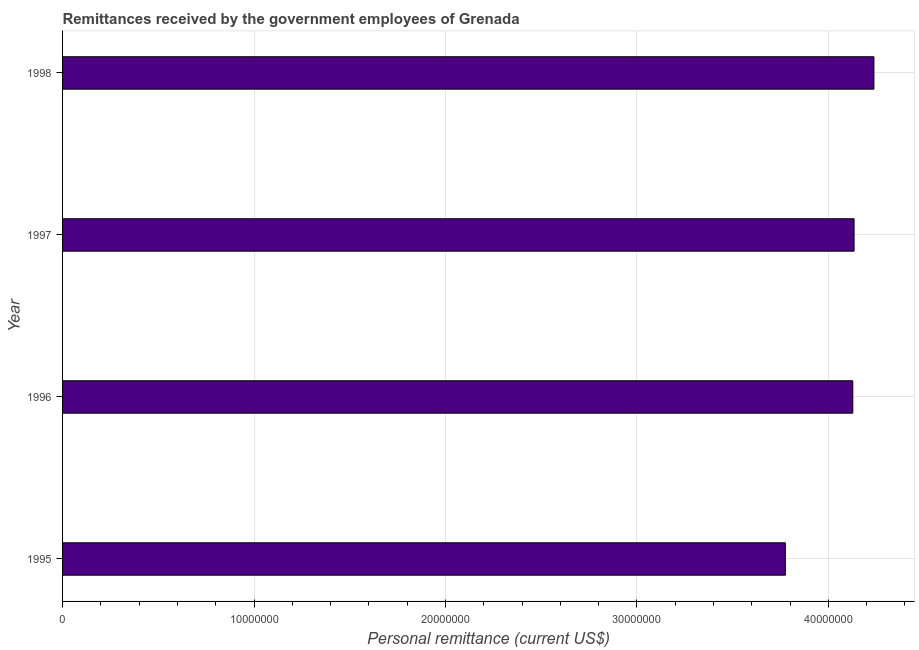What is the title of the graph?
Provide a short and direct response. Remittances received by the government employees of Grenada. What is the label or title of the X-axis?
Offer a very short reply. Personal remittance (current US$). What is the label or title of the Y-axis?
Your answer should be compact. Year. What is the personal remittances in 1998?
Make the answer very short. 4.24e+07. Across all years, what is the maximum personal remittances?
Give a very brief answer. 4.24e+07. Across all years, what is the minimum personal remittances?
Offer a very short reply. 3.78e+07. In which year was the personal remittances minimum?
Offer a very short reply. 1995. What is the sum of the personal remittances?
Your answer should be very brief. 1.63e+08. What is the difference between the personal remittances in 1995 and 1996?
Your answer should be compact. -3.52e+06. What is the average personal remittances per year?
Provide a short and direct response. 4.07e+07. What is the median personal remittances?
Ensure brevity in your answer.  4.13e+07. What is the ratio of the personal remittances in 1997 to that in 1998?
Your answer should be very brief. 0.98. Is the difference between the personal remittances in 1996 and 1997 greater than the difference between any two years?
Offer a terse response. No. What is the difference between the highest and the second highest personal remittances?
Your answer should be very brief. 1.04e+06. Is the sum of the personal remittances in 1997 and 1998 greater than the maximum personal remittances across all years?
Your answer should be very brief. Yes. What is the difference between the highest and the lowest personal remittances?
Offer a terse response. 4.63e+06. In how many years, is the personal remittances greater than the average personal remittances taken over all years?
Your response must be concise. 3. Are all the bars in the graph horizontal?
Your response must be concise. Yes. How many years are there in the graph?
Your answer should be compact. 4. Are the values on the major ticks of X-axis written in scientific E-notation?
Your answer should be compact. No. What is the Personal remittance (current US$) in 1995?
Provide a succinct answer. 3.78e+07. What is the Personal remittance (current US$) in 1996?
Your response must be concise. 4.13e+07. What is the Personal remittance (current US$) in 1997?
Provide a short and direct response. 4.13e+07. What is the Personal remittance (current US$) of 1998?
Offer a very short reply. 4.24e+07. What is the difference between the Personal remittance (current US$) in 1995 and 1996?
Make the answer very short. -3.52e+06. What is the difference between the Personal remittance (current US$) in 1995 and 1997?
Ensure brevity in your answer.  -3.59e+06. What is the difference between the Personal remittance (current US$) in 1995 and 1998?
Give a very brief answer. -4.63e+06. What is the difference between the Personal remittance (current US$) in 1996 and 1997?
Provide a succinct answer. -6.67e+04. What is the difference between the Personal remittance (current US$) in 1996 and 1998?
Offer a terse response. -1.10e+06. What is the difference between the Personal remittance (current US$) in 1997 and 1998?
Ensure brevity in your answer.  -1.04e+06. What is the ratio of the Personal remittance (current US$) in 1995 to that in 1996?
Provide a short and direct response. 0.92. What is the ratio of the Personal remittance (current US$) in 1995 to that in 1997?
Your answer should be compact. 0.91. What is the ratio of the Personal remittance (current US$) in 1995 to that in 1998?
Give a very brief answer. 0.89. What is the ratio of the Personal remittance (current US$) in 1996 to that in 1997?
Offer a terse response. 1. What is the ratio of the Personal remittance (current US$) in 1997 to that in 1998?
Your answer should be very brief. 0.98. 